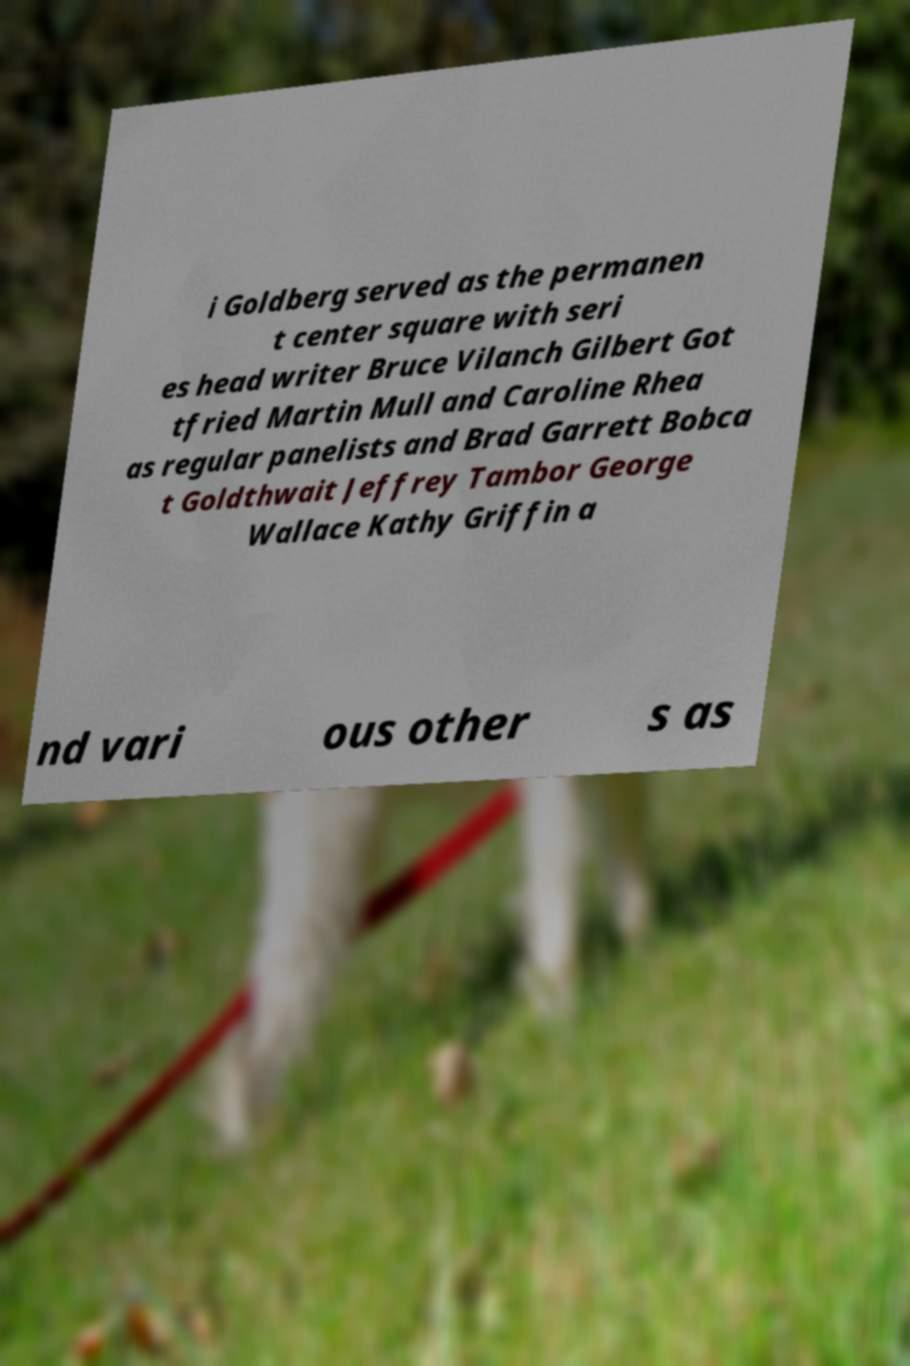For documentation purposes, I need the text within this image transcribed. Could you provide that? i Goldberg served as the permanen t center square with seri es head writer Bruce Vilanch Gilbert Got tfried Martin Mull and Caroline Rhea as regular panelists and Brad Garrett Bobca t Goldthwait Jeffrey Tambor George Wallace Kathy Griffin a nd vari ous other s as 